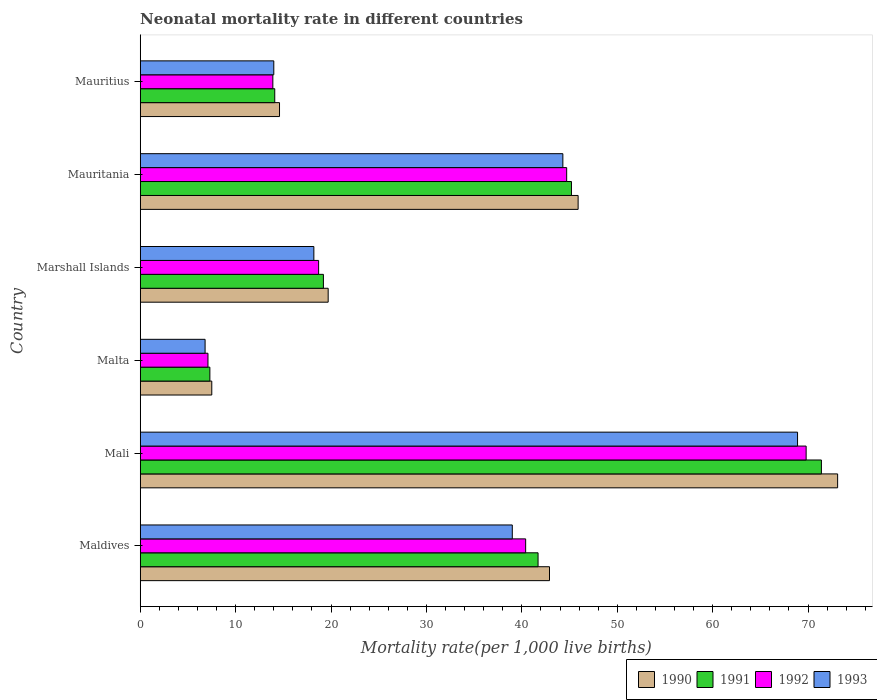How many bars are there on the 3rd tick from the bottom?
Offer a very short reply. 4. What is the label of the 6th group of bars from the top?
Make the answer very short. Maldives. In how many cases, is the number of bars for a given country not equal to the number of legend labels?
Make the answer very short. 0. What is the neonatal mortality rate in 1990 in Mali?
Your response must be concise. 73.1. Across all countries, what is the maximum neonatal mortality rate in 1993?
Ensure brevity in your answer.  68.9. In which country was the neonatal mortality rate in 1993 maximum?
Offer a very short reply. Mali. In which country was the neonatal mortality rate in 1990 minimum?
Your answer should be very brief. Malta. What is the total neonatal mortality rate in 1993 in the graph?
Provide a succinct answer. 191.2. What is the difference between the neonatal mortality rate in 1990 in Mali and that in Mauritius?
Your response must be concise. 58.5. What is the difference between the neonatal mortality rate in 1993 in Mauritania and the neonatal mortality rate in 1991 in Mali?
Your answer should be very brief. -27.1. What is the average neonatal mortality rate in 1990 per country?
Give a very brief answer. 33.95. What is the difference between the neonatal mortality rate in 1990 and neonatal mortality rate in 1991 in Mali?
Ensure brevity in your answer.  1.7. In how many countries, is the neonatal mortality rate in 1990 greater than 62 ?
Offer a very short reply. 1. Is the neonatal mortality rate in 1991 in Mali less than that in Mauritius?
Keep it short and to the point. No. What is the difference between the highest and the second highest neonatal mortality rate in 1993?
Your answer should be compact. 24.6. What is the difference between the highest and the lowest neonatal mortality rate in 1990?
Give a very brief answer. 65.6. Is the sum of the neonatal mortality rate in 1990 in Mali and Marshall Islands greater than the maximum neonatal mortality rate in 1993 across all countries?
Ensure brevity in your answer.  Yes. What does the 2nd bar from the top in Marshall Islands represents?
Give a very brief answer. 1992. How many bars are there?
Your answer should be very brief. 24. Are all the bars in the graph horizontal?
Your answer should be compact. Yes. How many countries are there in the graph?
Your answer should be very brief. 6. What is the difference between two consecutive major ticks on the X-axis?
Your response must be concise. 10. Are the values on the major ticks of X-axis written in scientific E-notation?
Your answer should be compact. No. Does the graph contain grids?
Make the answer very short. No. How many legend labels are there?
Offer a very short reply. 4. What is the title of the graph?
Your answer should be compact. Neonatal mortality rate in different countries. What is the label or title of the X-axis?
Provide a succinct answer. Mortality rate(per 1,0 live births). What is the Mortality rate(per 1,000 live births) in 1990 in Maldives?
Provide a short and direct response. 42.9. What is the Mortality rate(per 1,000 live births) of 1991 in Maldives?
Your answer should be compact. 41.7. What is the Mortality rate(per 1,000 live births) of 1992 in Maldives?
Make the answer very short. 40.4. What is the Mortality rate(per 1,000 live births) in 1993 in Maldives?
Your response must be concise. 39. What is the Mortality rate(per 1,000 live births) of 1990 in Mali?
Your answer should be very brief. 73.1. What is the Mortality rate(per 1,000 live births) of 1991 in Mali?
Your response must be concise. 71.4. What is the Mortality rate(per 1,000 live births) in 1992 in Mali?
Offer a terse response. 69.8. What is the Mortality rate(per 1,000 live births) in 1993 in Mali?
Your answer should be compact. 68.9. What is the Mortality rate(per 1,000 live births) in 1991 in Malta?
Your answer should be very brief. 7.3. What is the Mortality rate(per 1,000 live births) of 1992 in Malta?
Your answer should be compact. 7.1. What is the Mortality rate(per 1,000 live births) of 1993 in Marshall Islands?
Keep it short and to the point. 18.2. What is the Mortality rate(per 1,000 live births) of 1990 in Mauritania?
Offer a terse response. 45.9. What is the Mortality rate(per 1,000 live births) of 1991 in Mauritania?
Your answer should be compact. 45.2. What is the Mortality rate(per 1,000 live births) of 1992 in Mauritania?
Provide a succinct answer. 44.7. What is the Mortality rate(per 1,000 live births) of 1993 in Mauritania?
Ensure brevity in your answer.  44.3. What is the Mortality rate(per 1,000 live births) of 1991 in Mauritius?
Your answer should be compact. 14.1. What is the Mortality rate(per 1,000 live births) in 1993 in Mauritius?
Provide a succinct answer. 14. Across all countries, what is the maximum Mortality rate(per 1,000 live births) of 1990?
Your answer should be very brief. 73.1. Across all countries, what is the maximum Mortality rate(per 1,000 live births) of 1991?
Give a very brief answer. 71.4. Across all countries, what is the maximum Mortality rate(per 1,000 live births) in 1992?
Give a very brief answer. 69.8. Across all countries, what is the maximum Mortality rate(per 1,000 live births) in 1993?
Make the answer very short. 68.9. Across all countries, what is the minimum Mortality rate(per 1,000 live births) in 1991?
Ensure brevity in your answer.  7.3. Across all countries, what is the minimum Mortality rate(per 1,000 live births) of 1992?
Keep it short and to the point. 7.1. What is the total Mortality rate(per 1,000 live births) of 1990 in the graph?
Your response must be concise. 203.7. What is the total Mortality rate(per 1,000 live births) in 1991 in the graph?
Your answer should be compact. 198.9. What is the total Mortality rate(per 1,000 live births) of 1992 in the graph?
Your answer should be compact. 194.6. What is the total Mortality rate(per 1,000 live births) of 1993 in the graph?
Offer a very short reply. 191.2. What is the difference between the Mortality rate(per 1,000 live births) in 1990 in Maldives and that in Mali?
Make the answer very short. -30.2. What is the difference between the Mortality rate(per 1,000 live births) in 1991 in Maldives and that in Mali?
Make the answer very short. -29.7. What is the difference between the Mortality rate(per 1,000 live births) of 1992 in Maldives and that in Mali?
Your response must be concise. -29.4. What is the difference between the Mortality rate(per 1,000 live births) of 1993 in Maldives and that in Mali?
Provide a short and direct response. -29.9. What is the difference between the Mortality rate(per 1,000 live births) of 1990 in Maldives and that in Malta?
Offer a very short reply. 35.4. What is the difference between the Mortality rate(per 1,000 live births) of 1991 in Maldives and that in Malta?
Your response must be concise. 34.4. What is the difference between the Mortality rate(per 1,000 live births) in 1992 in Maldives and that in Malta?
Give a very brief answer. 33.3. What is the difference between the Mortality rate(per 1,000 live births) in 1993 in Maldives and that in Malta?
Make the answer very short. 32.2. What is the difference between the Mortality rate(per 1,000 live births) of 1990 in Maldives and that in Marshall Islands?
Provide a succinct answer. 23.2. What is the difference between the Mortality rate(per 1,000 live births) of 1992 in Maldives and that in Marshall Islands?
Offer a very short reply. 21.7. What is the difference between the Mortality rate(per 1,000 live births) of 1993 in Maldives and that in Marshall Islands?
Provide a succinct answer. 20.8. What is the difference between the Mortality rate(per 1,000 live births) of 1991 in Maldives and that in Mauritania?
Offer a terse response. -3.5. What is the difference between the Mortality rate(per 1,000 live births) of 1992 in Maldives and that in Mauritania?
Your response must be concise. -4.3. What is the difference between the Mortality rate(per 1,000 live births) of 1990 in Maldives and that in Mauritius?
Give a very brief answer. 28.3. What is the difference between the Mortality rate(per 1,000 live births) of 1991 in Maldives and that in Mauritius?
Provide a succinct answer. 27.6. What is the difference between the Mortality rate(per 1,000 live births) of 1992 in Maldives and that in Mauritius?
Provide a succinct answer. 26.5. What is the difference between the Mortality rate(per 1,000 live births) in 1993 in Maldives and that in Mauritius?
Make the answer very short. 25. What is the difference between the Mortality rate(per 1,000 live births) in 1990 in Mali and that in Malta?
Your answer should be compact. 65.6. What is the difference between the Mortality rate(per 1,000 live births) of 1991 in Mali and that in Malta?
Give a very brief answer. 64.1. What is the difference between the Mortality rate(per 1,000 live births) in 1992 in Mali and that in Malta?
Provide a succinct answer. 62.7. What is the difference between the Mortality rate(per 1,000 live births) in 1993 in Mali and that in Malta?
Your response must be concise. 62.1. What is the difference between the Mortality rate(per 1,000 live births) in 1990 in Mali and that in Marshall Islands?
Keep it short and to the point. 53.4. What is the difference between the Mortality rate(per 1,000 live births) of 1991 in Mali and that in Marshall Islands?
Your answer should be very brief. 52.2. What is the difference between the Mortality rate(per 1,000 live births) in 1992 in Mali and that in Marshall Islands?
Ensure brevity in your answer.  51.1. What is the difference between the Mortality rate(per 1,000 live births) of 1993 in Mali and that in Marshall Islands?
Ensure brevity in your answer.  50.7. What is the difference between the Mortality rate(per 1,000 live births) of 1990 in Mali and that in Mauritania?
Ensure brevity in your answer.  27.2. What is the difference between the Mortality rate(per 1,000 live births) of 1991 in Mali and that in Mauritania?
Offer a very short reply. 26.2. What is the difference between the Mortality rate(per 1,000 live births) in 1992 in Mali and that in Mauritania?
Your answer should be compact. 25.1. What is the difference between the Mortality rate(per 1,000 live births) in 1993 in Mali and that in Mauritania?
Your answer should be compact. 24.6. What is the difference between the Mortality rate(per 1,000 live births) of 1990 in Mali and that in Mauritius?
Give a very brief answer. 58.5. What is the difference between the Mortality rate(per 1,000 live births) in 1991 in Mali and that in Mauritius?
Offer a very short reply. 57.3. What is the difference between the Mortality rate(per 1,000 live births) in 1992 in Mali and that in Mauritius?
Your response must be concise. 55.9. What is the difference between the Mortality rate(per 1,000 live births) in 1993 in Mali and that in Mauritius?
Keep it short and to the point. 54.9. What is the difference between the Mortality rate(per 1,000 live births) of 1992 in Malta and that in Marshall Islands?
Provide a succinct answer. -11.6. What is the difference between the Mortality rate(per 1,000 live births) in 1993 in Malta and that in Marshall Islands?
Keep it short and to the point. -11.4. What is the difference between the Mortality rate(per 1,000 live births) in 1990 in Malta and that in Mauritania?
Make the answer very short. -38.4. What is the difference between the Mortality rate(per 1,000 live births) of 1991 in Malta and that in Mauritania?
Your answer should be very brief. -37.9. What is the difference between the Mortality rate(per 1,000 live births) in 1992 in Malta and that in Mauritania?
Your response must be concise. -37.6. What is the difference between the Mortality rate(per 1,000 live births) in 1993 in Malta and that in Mauritania?
Ensure brevity in your answer.  -37.5. What is the difference between the Mortality rate(per 1,000 live births) of 1991 in Malta and that in Mauritius?
Your answer should be very brief. -6.8. What is the difference between the Mortality rate(per 1,000 live births) of 1992 in Malta and that in Mauritius?
Your answer should be very brief. -6.8. What is the difference between the Mortality rate(per 1,000 live births) in 1990 in Marshall Islands and that in Mauritania?
Offer a very short reply. -26.2. What is the difference between the Mortality rate(per 1,000 live births) of 1991 in Marshall Islands and that in Mauritania?
Keep it short and to the point. -26. What is the difference between the Mortality rate(per 1,000 live births) in 1993 in Marshall Islands and that in Mauritania?
Offer a very short reply. -26.1. What is the difference between the Mortality rate(per 1,000 live births) in 1990 in Marshall Islands and that in Mauritius?
Offer a very short reply. 5.1. What is the difference between the Mortality rate(per 1,000 live births) of 1991 in Marshall Islands and that in Mauritius?
Offer a very short reply. 5.1. What is the difference between the Mortality rate(per 1,000 live births) of 1992 in Marshall Islands and that in Mauritius?
Offer a terse response. 4.8. What is the difference between the Mortality rate(per 1,000 live births) of 1993 in Marshall Islands and that in Mauritius?
Offer a very short reply. 4.2. What is the difference between the Mortality rate(per 1,000 live births) in 1990 in Mauritania and that in Mauritius?
Provide a short and direct response. 31.3. What is the difference between the Mortality rate(per 1,000 live births) in 1991 in Mauritania and that in Mauritius?
Keep it short and to the point. 31.1. What is the difference between the Mortality rate(per 1,000 live births) of 1992 in Mauritania and that in Mauritius?
Ensure brevity in your answer.  30.8. What is the difference between the Mortality rate(per 1,000 live births) in 1993 in Mauritania and that in Mauritius?
Ensure brevity in your answer.  30.3. What is the difference between the Mortality rate(per 1,000 live births) of 1990 in Maldives and the Mortality rate(per 1,000 live births) of 1991 in Mali?
Ensure brevity in your answer.  -28.5. What is the difference between the Mortality rate(per 1,000 live births) of 1990 in Maldives and the Mortality rate(per 1,000 live births) of 1992 in Mali?
Offer a terse response. -26.9. What is the difference between the Mortality rate(per 1,000 live births) in 1991 in Maldives and the Mortality rate(per 1,000 live births) in 1992 in Mali?
Offer a terse response. -28.1. What is the difference between the Mortality rate(per 1,000 live births) of 1991 in Maldives and the Mortality rate(per 1,000 live births) of 1993 in Mali?
Your answer should be very brief. -27.2. What is the difference between the Mortality rate(per 1,000 live births) of 1992 in Maldives and the Mortality rate(per 1,000 live births) of 1993 in Mali?
Give a very brief answer. -28.5. What is the difference between the Mortality rate(per 1,000 live births) of 1990 in Maldives and the Mortality rate(per 1,000 live births) of 1991 in Malta?
Give a very brief answer. 35.6. What is the difference between the Mortality rate(per 1,000 live births) in 1990 in Maldives and the Mortality rate(per 1,000 live births) in 1992 in Malta?
Your answer should be very brief. 35.8. What is the difference between the Mortality rate(per 1,000 live births) in 1990 in Maldives and the Mortality rate(per 1,000 live births) in 1993 in Malta?
Make the answer very short. 36.1. What is the difference between the Mortality rate(per 1,000 live births) in 1991 in Maldives and the Mortality rate(per 1,000 live births) in 1992 in Malta?
Keep it short and to the point. 34.6. What is the difference between the Mortality rate(per 1,000 live births) in 1991 in Maldives and the Mortality rate(per 1,000 live births) in 1993 in Malta?
Offer a very short reply. 34.9. What is the difference between the Mortality rate(per 1,000 live births) of 1992 in Maldives and the Mortality rate(per 1,000 live births) of 1993 in Malta?
Offer a terse response. 33.6. What is the difference between the Mortality rate(per 1,000 live births) of 1990 in Maldives and the Mortality rate(per 1,000 live births) of 1991 in Marshall Islands?
Your response must be concise. 23.7. What is the difference between the Mortality rate(per 1,000 live births) in 1990 in Maldives and the Mortality rate(per 1,000 live births) in 1992 in Marshall Islands?
Your answer should be very brief. 24.2. What is the difference between the Mortality rate(per 1,000 live births) of 1990 in Maldives and the Mortality rate(per 1,000 live births) of 1993 in Marshall Islands?
Offer a terse response. 24.7. What is the difference between the Mortality rate(per 1,000 live births) in 1991 in Maldives and the Mortality rate(per 1,000 live births) in 1992 in Marshall Islands?
Keep it short and to the point. 23. What is the difference between the Mortality rate(per 1,000 live births) of 1991 in Maldives and the Mortality rate(per 1,000 live births) of 1993 in Marshall Islands?
Your answer should be compact. 23.5. What is the difference between the Mortality rate(per 1,000 live births) in 1990 in Maldives and the Mortality rate(per 1,000 live births) in 1992 in Mauritania?
Your answer should be compact. -1.8. What is the difference between the Mortality rate(per 1,000 live births) in 1991 in Maldives and the Mortality rate(per 1,000 live births) in 1992 in Mauritania?
Your response must be concise. -3. What is the difference between the Mortality rate(per 1,000 live births) of 1991 in Maldives and the Mortality rate(per 1,000 live births) of 1993 in Mauritania?
Offer a terse response. -2.6. What is the difference between the Mortality rate(per 1,000 live births) of 1992 in Maldives and the Mortality rate(per 1,000 live births) of 1993 in Mauritania?
Offer a very short reply. -3.9. What is the difference between the Mortality rate(per 1,000 live births) of 1990 in Maldives and the Mortality rate(per 1,000 live births) of 1991 in Mauritius?
Give a very brief answer. 28.8. What is the difference between the Mortality rate(per 1,000 live births) in 1990 in Maldives and the Mortality rate(per 1,000 live births) in 1992 in Mauritius?
Provide a succinct answer. 29. What is the difference between the Mortality rate(per 1,000 live births) in 1990 in Maldives and the Mortality rate(per 1,000 live births) in 1993 in Mauritius?
Make the answer very short. 28.9. What is the difference between the Mortality rate(per 1,000 live births) in 1991 in Maldives and the Mortality rate(per 1,000 live births) in 1992 in Mauritius?
Give a very brief answer. 27.8. What is the difference between the Mortality rate(per 1,000 live births) in 1991 in Maldives and the Mortality rate(per 1,000 live births) in 1993 in Mauritius?
Give a very brief answer. 27.7. What is the difference between the Mortality rate(per 1,000 live births) in 1992 in Maldives and the Mortality rate(per 1,000 live births) in 1993 in Mauritius?
Make the answer very short. 26.4. What is the difference between the Mortality rate(per 1,000 live births) in 1990 in Mali and the Mortality rate(per 1,000 live births) in 1991 in Malta?
Offer a very short reply. 65.8. What is the difference between the Mortality rate(per 1,000 live births) of 1990 in Mali and the Mortality rate(per 1,000 live births) of 1992 in Malta?
Offer a terse response. 66. What is the difference between the Mortality rate(per 1,000 live births) in 1990 in Mali and the Mortality rate(per 1,000 live births) in 1993 in Malta?
Keep it short and to the point. 66.3. What is the difference between the Mortality rate(per 1,000 live births) of 1991 in Mali and the Mortality rate(per 1,000 live births) of 1992 in Malta?
Keep it short and to the point. 64.3. What is the difference between the Mortality rate(per 1,000 live births) of 1991 in Mali and the Mortality rate(per 1,000 live births) of 1993 in Malta?
Keep it short and to the point. 64.6. What is the difference between the Mortality rate(per 1,000 live births) in 1990 in Mali and the Mortality rate(per 1,000 live births) in 1991 in Marshall Islands?
Offer a terse response. 53.9. What is the difference between the Mortality rate(per 1,000 live births) in 1990 in Mali and the Mortality rate(per 1,000 live births) in 1992 in Marshall Islands?
Make the answer very short. 54.4. What is the difference between the Mortality rate(per 1,000 live births) in 1990 in Mali and the Mortality rate(per 1,000 live births) in 1993 in Marshall Islands?
Provide a succinct answer. 54.9. What is the difference between the Mortality rate(per 1,000 live births) of 1991 in Mali and the Mortality rate(per 1,000 live births) of 1992 in Marshall Islands?
Give a very brief answer. 52.7. What is the difference between the Mortality rate(per 1,000 live births) of 1991 in Mali and the Mortality rate(per 1,000 live births) of 1993 in Marshall Islands?
Provide a short and direct response. 53.2. What is the difference between the Mortality rate(per 1,000 live births) of 1992 in Mali and the Mortality rate(per 1,000 live births) of 1993 in Marshall Islands?
Keep it short and to the point. 51.6. What is the difference between the Mortality rate(per 1,000 live births) of 1990 in Mali and the Mortality rate(per 1,000 live births) of 1991 in Mauritania?
Ensure brevity in your answer.  27.9. What is the difference between the Mortality rate(per 1,000 live births) of 1990 in Mali and the Mortality rate(per 1,000 live births) of 1992 in Mauritania?
Your answer should be compact. 28.4. What is the difference between the Mortality rate(per 1,000 live births) of 1990 in Mali and the Mortality rate(per 1,000 live births) of 1993 in Mauritania?
Your response must be concise. 28.8. What is the difference between the Mortality rate(per 1,000 live births) in 1991 in Mali and the Mortality rate(per 1,000 live births) in 1992 in Mauritania?
Make the answer very short. 26.7. What is the difference between the Mortality rate(per 1,000 live births) of 1991 in Mali and the Mortality rate(per 1,000 live births) of 1993 in Mauritania?
Keep it short and to the point. 27.1. What is the difference between the Mortality rate(per 1,000 live births) of 1990 in Mali and the Mortality rate(per 1,000 live births) of 1992 in Mauritius?
Give a very brief answer. 59.2. What is the difference between the Mortality rate(per 1,000 live births) of 1990 in Mali and the Mortality rate(per 1,000 live births) of 1993 in Mauritius?
Provide a succinct answer. 59.1. What is the difference between the Mortality rate(per 1,000 live births) of 1991 in Mali and the Mortality rate(per 1,000 live births) of 1992 in Mauritius?
Keep it short and to the point. 57.5. What is the difference between the Mortality rate(per 1,000 live births) of 1991 in Mali and the Mortality rate(per 1,000 live births) of 1993 in Mauritius?
Keep it short and to the point. 57.4. What is the difference between the Mortality rate(per 1,000 live births) in 1992 in Mali and the Mortality rate(per 1,000 live births) in 1993 in Mauritius?
Your answer should be very brief. 55.8. What is the difference between the Mortality rate(per 1,000 live births) of 1990 in Malta and the Mortality rate(per 1,000 live births) of 1992 in Marshall Islands?
Offer a terse response. -11.2. What is the difference between the Mortality rate(per 1,000 live births) in 1990 in Malta and the Mortality rate(per 1,000 live births) in 1993 in Marshall Islands?
Your answer should be compact. -10.7. What is the difference between the Mortality rate(per 1,000 live births) in 1991 in Malta and the Mortality rate(per 1,000 live births) in 1992 in Marshall Islands?
Ensure brevity in your answer.  -11.4. What is the difference between the Mortality rate(per 1,000 live births) of 1992 in Malta and the Mortality rate(per 1,000 live births) of 1993 in Marshall Islands?
Offer a terse response. -11.1. What is the difference between the Mortality rate(per 1,000 live births) of 1990 in Malta and the Mortality rate(per 1,000 live births) of 1991 in Mauritania?
Ensure brevity in your answer.  -37.7. What is the difference between the Mortality rate(per 1,000 live births) of 1990 in Malta and the Mortality rate(per 1,000 live births) of 1992 in Mauritania?
Keep it short and to the point. -37.2. What is the difference between the Mortality rate(per 1,000 live births) of 1990 in Malta and the Mortality rate(per 1,000 live births) of 1993 in Mauritania?
Ensure brevity in your answer.  -36.8. What is the difference between the Mortality rate(per 1,000 live births) of 1991 in Malta and the Mortality rate(per 1,000 live births) of 1992 in Mauritania?
Your response must be concise. -37.4. What is the difference between the Mortality rate(per 1,000 live births) of 1991 in Malta and the Mortality rate(per 1,000 live births) of 1993 in Mauritania?
Make the answer very short. -37. What is the difference between the Mortality rate(per 1,000 live births) in 1992 in Malta and the Mortality rate(per 1,000 live births) in 1993 in Mauritania?
Your answer should be compact. -37.2. What is the difference between the Mortality rate(per 1,000 live births) of 1990 in Malta and the Mortality rate(per 1,000 live births) of 1991 in Mauritius?
Offer a terse response. -6.6. What is the difference between the Mortality rate(per 1,000 live births) of 1990 in Malta and the Mortality rate(per 1,000 live births) of 1992 in Mauritius?
Your answer should be compact. -6.4. What is the difference between the Mortality rate(per 1,000 live births) in 1991 in Malta and the Mortality rate(per 1,000 live births) in 1993 in Mauritius?
Your answer should be very brief. -6.7. What is the difference between the Mortality rate(per 1,000 live births) of 1990 in Marshall Islands and the Mortality rate(per 1,000 live births) of 1991 in Mauritania?
Offer a terse response. -25.5. What is the difference between the Mortality rate(per 1,000 live births) of 1990 in Marshall Islands and the Mortality rate(per 1,000 live births) of 1993 in Mauritania?
Give a very brief answer. -24.6. What is the difference between the Mortality rate(per 1,000 live births) of 1991 in Marshall Islands and the Mortality rate(per 1,000 live births) of 1992 in Mauritania?
Your response must be concise. -25.5. What is the difference between the Mortality rate(per 1,000 live births) of 1991 in Marshall Islands and the Mortality rate(per 1,000 live births) of 1993 in Mauritania?
Provide a succinct answer. -25.1. What is the difference between the Mortality rate(per 1,000 live births) of 1992 in Marshall Islands and the Mortality rate(per 1,000 live births) of 1993 in Mauritania?
Give a very brief answer. -25.6. What is the difference between the Mortality rate(per 1,000 live births) in 1990 in Marshall Islands and the Mortality rate(per 1,000 live births) in 1991 in Mauritius?
Your answer should be compact. 5.6. What is the difference between the Mortality rate(per 1,000 live births) of 1990 in Marshall Islands and the Mortality rate(per 1,000 live births) of 1992 in Mauritius?
Your answer should be very brief. 5.8. What is the difference between the Mortality rate(per 1,000 live births) in 1991 in Marshall Islands and the Mortality rate(per 1,000 live births) in 1993 in Mauritius?
Your answer should be very brief. 5.2. What is the difference between the Mortality rate(per 1,000 live births) in 1990 in Mauritania and the Mortality rate(per 1,000 live births) in 1991 in Mauritius?
Your response must be concise. 31.8. What is the difference between the Mortality rate(per 1,000 live births) of 1990 in Mauritania and the Mortality rate(per 1,000 live births) of 1993 in Mauritius?
Give a very brief answer. 31.9. What is the difference between the Mortality rate(per 1,000 live births) of 1991 in Mauritania and the Mortality rate(per 1,000 live births) of 1992 in Mauritius?
Your response must be concise. 31.3. What is the difference between the Mortality rate(per 1,000 live births) of 1991 in Mauritania and the Mortality rate(per 1,000 live births) of 1993 in Mauritius?
Keep it short and to the point. 31.2. What is the difference between the Mortality rate(per 1,000 live births) in 1992 in Mauritania and the Mortality rate(per 1,000 live births) in 1993 in Mauritius?
Ensure brevity in your answer.  30.7. What is the average Mortality rate(per 1,000 live births) in 1990 per country?
Your answer should be compact. 33.95. What is the average Mortality rate(per 1,000 live births) of 1991 per country?
Offer a terse response. 33.15. What is the average Mortality rate(per 1,000 live births) in 1992 per country?
Your answer should be compact. 32.43. What is the average Mortality rate(per 1,000 live births) in 1993 per country?
Offer a terse response. 31.87. What is the difference between the Mortality rate(per 1,000 live births) of 1990 and Mortality rate(per 1,000 live births) of 1992 in Maldives?
Keep it short and to the point. 2.5. What is the difference between the Mortality rate(per 1,000 live births) of 1991 and Mortality rate(per 1,000 live births) of 1992 in Maldives?
Give a very brief answer. 1.3. What is the difference between the Mortality rate(per 1,000 live births) of 1991 and Mortality rate(per 1,000 live births) of 1993 in Maldives?
Your response must be concise. 2.7. What is the difference between the Mortality rate(per 1,000 live births) of 1992 and Mortality rate(per 1,000 live births) of 1993 in Maldives?
Your answer should be very brief. 1.4. What is the difference between the Mortality rate(per 1,000 live births) of 1990 and Mortality rate(per 1,000 live births) of 1991 in Mali?
Your answer should be very brief. 1.7. What is the difference between the Mortality rate(per 1,000 live births) in 1990 and Mortality rate(per 1,000 live births) in 1993 in Mali?
Ensure brevity in your answer.  4.2. What is the difference between the Mortality rate(per 1,000 live births) of 1991 and Mortality rate(per 1,000 live births) of 1992 in Mali?
Make the answer very short. 1.6. What is the difference between the Mortality rate(per 1,000 live births) in 1991 and Mortality rate(per 1,000 live births) in 1993 in Mali?
Your answer should be compact. 2.5. What is the difference between the Mortality rate(per 1,000 live births) in 1990 and Mortality rate(per 1,000 live births) in 1991 in Malta?
Your answer should be compact. 0.2. What is the difference between the Mortality rate(per 1,000 live births) in 1990 and Mortality rate(per 1,000 live births) in 1992 in Malta?
Your response must be concise. 0.4. What is the difference between the Mortality rate(per 1,000 live births) in 1990 and Mortality rate(per 1,000 live births) in 1993 in Malta?
Your response must be concise. 0.7. What is the difference between the Mortality rate(per 1,000 live births) in 1991 and Mortality rate(per 1,000 live births) in 1993 in Malta?
Keep it short and to the point. 0.5. What is the difference between the Mortality rate(per 1,000 live births) of 1992 and Mortality rate(per 1,000 live births) of 1993 in Malta?
Your response must be concise. 0.3. What is the difference between the Mortality rate(per 1,000 live births) of 1990 and Mortality rate(per 1,000 live births) of 1992 in Marshall Islands?
Offer a very short reply. 1. What is the difference between the Mortality rate(per 1,000 live births) of 1990 and Mortality rate(per 1,000 live births) of 1993 in Marshall Islands?
Keep it short and to the point. 1.5. What is the difference between the Mortality rate(per 1,000 live births) in 1991 and Mortality rate(per 1,000 live births) in 1992 in Marshall Islands?
Your answer should be very brief. 0.5. What is the difference between the Mortality rate(per 1,000 live births) of 1992 and Mortality rate(per 1,000 live births) of 1993 in Marshall Islands?
Give a very brief answer. 0.5. What is the difference between the Mortality rate(per 1,000 live births) in 1990 and Mortality rate(per 1,000 live births) in 1991 in Mauritania?
Give a very brief answer. 0.7. What is the difference between the Mortality rate(per 1,000 live births) of 1990 and Mortality rate(per 1,000 live births) of 1993 in Mauritania?
Your response must be concise. 1.6. What is the difference between the Mortality rate(per 1,000 live births) in 1990 and Mortality rate(per 1,000 live births) in 1991 in Mauritius?
Your answer should be very brief. 0.5. What is the difference between the Mortality rate(per 1,000 live births) in 1990 and Mortality rate(per 1,000 live births) in 1993 in Mauritius?
Offer a terse response. 0.6. What is the difference between the Mortality rate(per 1,000 live births) in 1991 and Mortality rate(per 1,000 live births) in 1992 in Mauritius?
Provide a succinct answer. 0.2. What is the difference between the Mortality rate(per 1,000 live births) in 1992 and Mortality rate(per 1,000 live births) in 1993 in Mauritius?
Make the answer very short. -0.1. What is the ratio of the Mortality rate(per 1,000 live births) in 1990 in Maldives to that in Mali?
Keep it short and to the point. 0.59. What is the ratio of the Mortality rate(per 1,000 live births) of 1991 in Maldives to that in Mali?
Provide a short and direct response. 0.58. What is the ratio of the Mortality rate(per 1,000 live births) of 1992 in Maldives to that in Mali?
Make the answer very short. 0.58. What is the ratio of the Mortality rate(per 1,000 live births) in 1993 in Maldives to that in Mali?
Your response must be concise. 0.57. What is the ratio of the Mortality rate(per 1,000 live births) in 1990 in Maldives to that in Malta?
Offer a terse response. 5.72. What is the ratio of the Mortality rate(per 1,000 live births) of 1991 in Maldives to that in Malta?
Offer a terse response. 5.71. What is the ratio of the Mortality rate(per 1,000 live births) in 1992 in Maldives to that in Malta?
Give a very brief answer. 5.69. What is the ratio of the Mortality rate(per 1,000 live births) of 1993 in Maldives to that in Malta?
Keep it short and to the point. 5.74. What is the ratio of the Mortality rate(per 1,000 live births) of 1990 in Maldives to that in Marshall Islands?
Keep it short and to the point. 2.18. What is the ratio of the Mortality rate(per 1,000 live births) in 1991 in Maldives to that in Marshall Islands?
Offer a very short reply. 2.17. What is the ratio of the Mortality rate(per 1,000 live births) of 1992 in Maldives to that in Marshall Islands?
Provide a succinct answer. 2.16. What is the ratio of the Mortality rate(per 1,000 live births) of 1993 in Maldives to that in Marshall Islands?
Give a very brief answer. 2.14. What is the ratio of the Mortality rate(per 1,000 live births) of 1990 in Maldives to that in Mauritania?
Make the answer very short. 0.93. What is the ratio of the Mortality rate(per 1,000 live births) in 1991 in Maldives to that in Mauritania?
Make the answer very short. 0.92. What is the ratio of the Mortality rate(per 1,000 live births) of 1992 in Maldives to that in Mauritania?
Ensure brevity in your answer.  0.9. What is the ratio of the Mortality rate(per 1,000 live births) in 1993 in Maldives to that in Mauritania?
Offer a very short reply. 0.88. What is the ratio of the Mortality rate(per 1,000 live births) in 1990 in Maldives to that in Mauritius?
Keep it short and to the point. 2.94. What is the ratio of the Mortality rate(per 1,000 live births) of 1991 in Maldives to that in Mauritius?
Your answer should be compact. 2.96. What is the ratio of the Mortality rate(per 1,000 live births) of 1992 in Maldives to that in Mauritius?
Give a very brief answer. 2.91. What is the ratio of the Mortality rate(per 1,000 live births) in 1993 in Maldives to that in Mauritius?
Your answer should be compact. 2.79. What is the ratio of the Mortality rate(per 1,000 live births) of 1990 in Mali to that in Malta?
Ensure brevity in your answer.  9.75. What is the ratio of the Mortality rate(per 1,000 live births) of 1991 in Mali to that in Malta?
Give a very brief answer. 9.78. What is the ratio of the Mortality rate(per 1,000 live births) of 1992 in Mali to that in Malta?
Your response must be concise. 9.83. What is the ratio of the Mortality rate(per 1,000 live births) in 1993 in Mali to that in Malta?
Keep it short and to the point. 10.13. What is the ratio of the Mortality rate(per 1,000 live births) of 1990 in Mali to that in Marshall Islands?
Your response must be concise. 3.71. What is the ratio of the Mortality rate(per 1,000 live births) of 1991 in Mali to that in Marshall Islands?
Your answer should be compact. 3.72. What is the ratio of the Mortality rate(per 1,000 live births) in 1992 in Mali to that in Marshall Islands?
Make the answer very short. 3.73. What is the ratio of the Mortality rate(per 1,000 live births) of 1993 in Mali to that in Marshall Islands?
Provide a succinct answer. 3.79. What is the ratio of the Mortality rate(per 1,000 live births) of 1990 in Mali to that in Mauritania?
Your answer should be very brief. 1.59. What is the ratio of the Mortality rate(per 1,000 live births) in 1991 in Mali to that in Mauritania?
Offer a terse response. 1.58. What is the ratio of the Mortality rate(per 1,000 live births) of 1992 in Mali to that in Mauritania?
Give a very brief answer. 1.56. What is the ratio of the Mortality rate(per 1,000 live births) of 1993 in Mali to that in Mauritania?
Your answer should be compact. 1.56. What is the ratio of the Mortality rate(per 1,000 live births) of 1990 in Mali to that in Mauritius?
Make the answer very short. 5.01. What is the ratio of the Mortality rate(per 1,000 live births) of 1991 in Mali to that in Mauritius?
Your answer should be very brief. 5.06. What is the ratio of the Mortality rate(per 1,000 live births) in 1992 in Mali to that in Mauritius?
Give a very brief answer. 5.02. What is the ratio of the Mortality rate(per 1,000 live births) of 1993 in Mali to that in Mauritius?
Your answer should be very brief. 4.92. What is the ratio of the Mortality rate(per 1,000 live births) in 1990 in Malta to that in Marshall Islands?
Provide a succinct answer. 0.38. What is the ratio of the Mortality rate(per 1,000 live births) of 1991 in Malta to that in Marshall Islands?
Give a very brief answer. 0.38. What is the ratio of the Mortality rate(per 1,000 live births) of 1992 in Malta to that in Marshall Islands?
Offer a very short reply. 0.38. What is the ratio of the Mortality rate(per 1,000 live births) in 1993 in Malta to that in Marshall Islands?
Make the answer very short. 0.37. What is the ratio of the Mortality rate(per 1,000 live births) in 1990 in Malta to that in Mauritania?
Offer a very short reply. 0.16. What is the ratio of the Mortality rate(per 1,000 live births) of 1991 in Malta to that in Mauritania?
Provide a short and direct response. 0.16. What is the ratio of the Mortality rate(per 1,000 live births) of 1992 in Malta to that in Mauritania?
Provide a short and direct response. 0.16. What is the ratio of the Mortality rate(per 1,000 live births) of 1993 in Malta to that in Mauritania?
Provide a succinct answer. 0.15. What is the ratio of the Mortality rate(per 1,000 live births) of 1990 in Malta to that in Mauritius?
Provide a succinct answer. 0.51. What is the ratio of the Mortality rate(per 1,000 live births) of 1991 in Malta to that in Mauritius?
Provide a short and direct response. 0.52. What is the ratio of the Mortality rate(per 1,000 live births) of 1992 in Malta to that in Mauritius?
Give a very brief answer. 0.51. What is the ratio of the Mortality rate(per 1,000 live births) in 1993 in Malta to that in Mauritius?
Your response must be concise. 0.49. What is the ratio of the Mortality rate(per 1,000 live births) of 1990 in Marshall Islands to that in Mauritania?
Ensure brevity in your answer.  0.43. What is the ratio of the Mortality rate(per 1,000 live births) in 1991 in Marshall Islands to that in Mauritania?
Ensure brevity in your answer.  0.42. What is the ratio of the Mortality rate(per 1,000 live births) in 1992 in Marshall Islands to that in Mauritania?
Offer a very short reply. 0.42. What is the ratio of the Mortality rate(per 1,000 live births) in 1993 in Marshall Islands to that in Mauritania?
Your answer should be very brief. 0.41. What is the ratio of the Mortality rate(per 1,000 live births) in 1990 in Marshall Islands to that in Mauritius?
Make the answer very short. 1.35. What is the ratio of the Mortality rate(per 1,000 live births) of 1991 in Marshall Islands to that in Mauritius?
Provide a short and direct response. 1.36. What is the ratio of the Mortality rate(per 1,000 live births) in 1992 in Marshall Islands to that in Mauritius?
Your answer should be very brief. 1.35. What is the ratio of the Mortality rate(per 1,000 live births) in 1990 in Mauritania to that in Mauritius?
Your answer should be very brief. 3.14. What is the ratio of the Mortality rate(per 1,000 live births) of 1991 in Mauritania to that in Mauritius?
Ensure brevity in your answer.  3.21. What is the ratio of the Mortality rate(per 1,000 live births) in 1992 in Mauritania to that in Mauritius?
Your response must be concise. 3.22. What is the ratio of the Mortality rate(per 1,000 live births) of 1993 in Mauritania to that in Mauritius?
Keep it short and to the point. 3.16. What is the difference between the highest and the second highest Mortality rate(per 1,000 live births) of 1990?
Your answer should be very brief. 27.2. What is the difference between the highest and the second highest Mortality rate(per 1,000 live births) in 1991?
Your answer should be compact. 26.2. What is the difference between the highest and the second highest Mortality rate(per 1,000 live births) of 1992?
Your answer should be very brief. 25.1. What is the difference between the highest and the second highest Mortality rate(per 1,000 live births) of 1993?
Your answer should be compact. 24.6. What is the difference between the highest and the lowest Mortality rate(per 1,000 live births) in 1990?
Your answer should be compact. 65.6. What is the difference between the highest and the lowest Mortality rate(per 1,000 live births) of 1991?
Your answer should be very brief. 64.1. What is the difference between the highest and the lowest Mortality rate(per 1,000 live births) of 1992?
Your answer should be compact. 62.7. What is the difference between the highest and the lowest Mortality rate(per 1,000 live births) of 1993?
Provide a succinct answer. 62.1. 